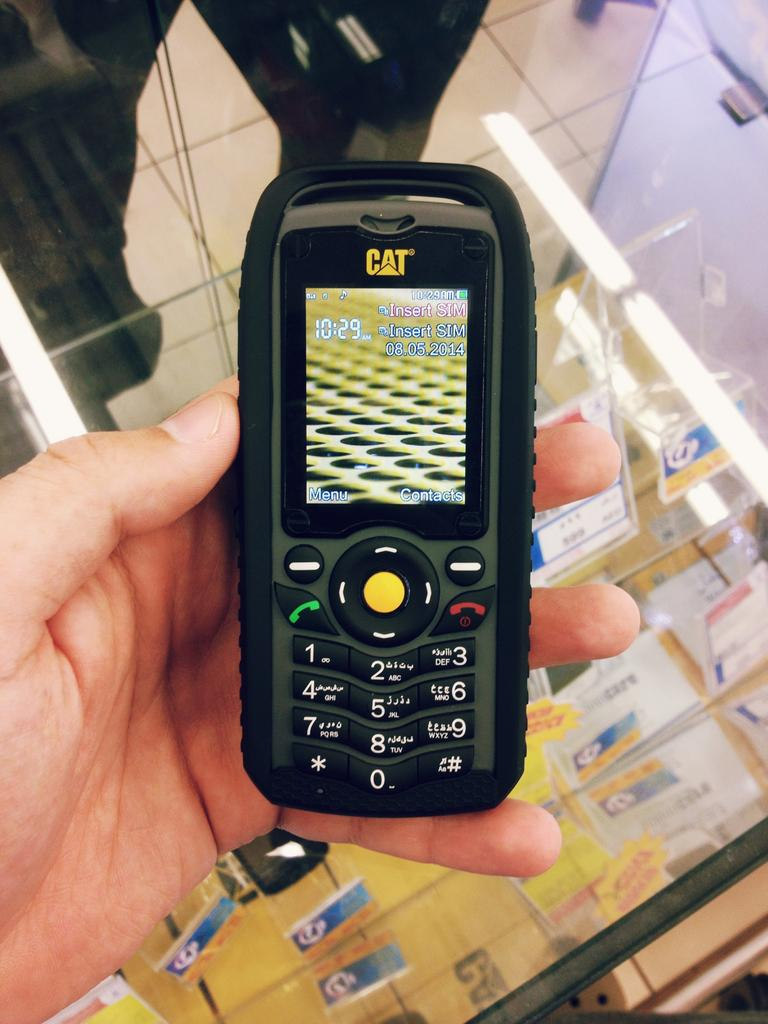<image>
Offer a succinct explanation of the picture presented. a cell phone that has the word cat on it 